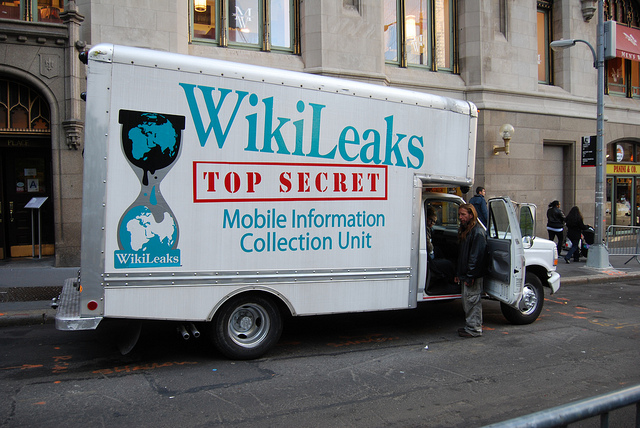<image>Is WikiLeaks a secret? I am not sure if WikiLeaks is a secret. However, it is generally considered not a secret. Is WikiLeaks a secret? I don't know if WikiLeaks is a secret. It can be both secret and not secret. 